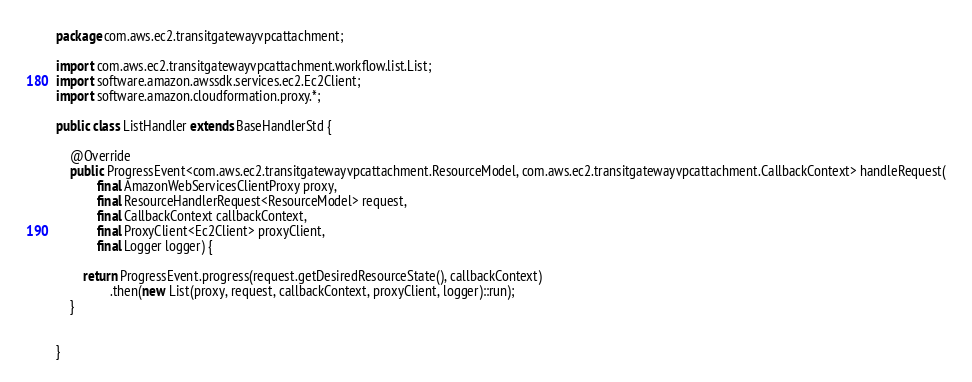<code> <loc_0><loc_0><loc_500><loc_500><_Java_>package com.aws.ec2.transitgatewayvpcattachment;

import com.aws.ec2.transitgatewayvpcattachment.workflow.list.List;
import software.amazon.awssdk.services.ec2.Ec2Client;
import software.amazon.cloudformation.proxy.*;

public class ListHandler extends BaseHandlerStd {

    @Override
    public ProgressEvent<com.aws.ec2.transitgatewayvpcattachment.ResourceModel, com.aws.ec2.transitgatewayvpcattachment.CallbackContext> handleRequest(
            final AmazonWebServicesClientProxy proxy,
            final ResourceHandlerRequest<ResourceModel> request,
            final CallbackContext callbackContext,
            final ProxyClient<Ec2Client> proxyClient,
            final Logger logger) {

        return ProgressEvent.progress(request.getDesiredResourceState(), callbackContext)
                .then(new List(proxy, request, callbackContext, proxyClient, logger)::run);
    }


}
</code> 